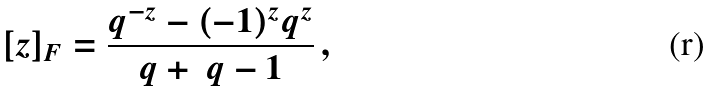Convert formula to latex. <formula><loc_0><loc_0><loc_500><loc_500>[ z ] _ { F } = \frac { q ^ { - z } - ( - 1 ) ^ { z } q ^ { z } } { q + \ q - 1 } \, ,</formula> 